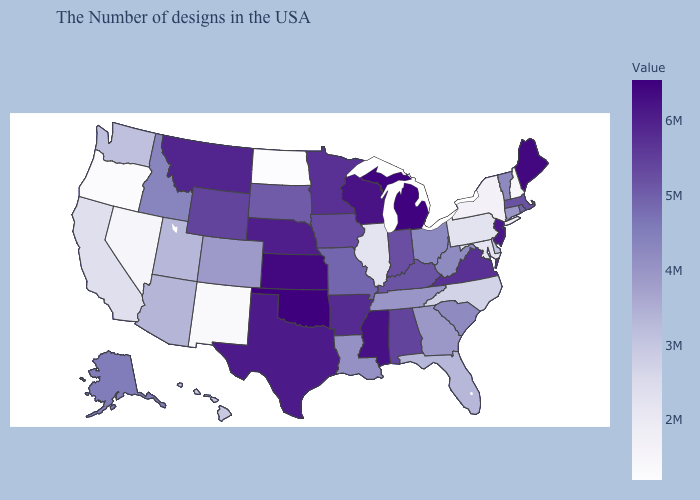Among the states that border Kansas , which have the highest value?
Write a very short answer. Oklahoma. Which states have the lowest value in the MidWest?
Quick response, please. North Dakota. Among the states that border Oregon , which have the lowest value?
Answer briefly. Nevada. 